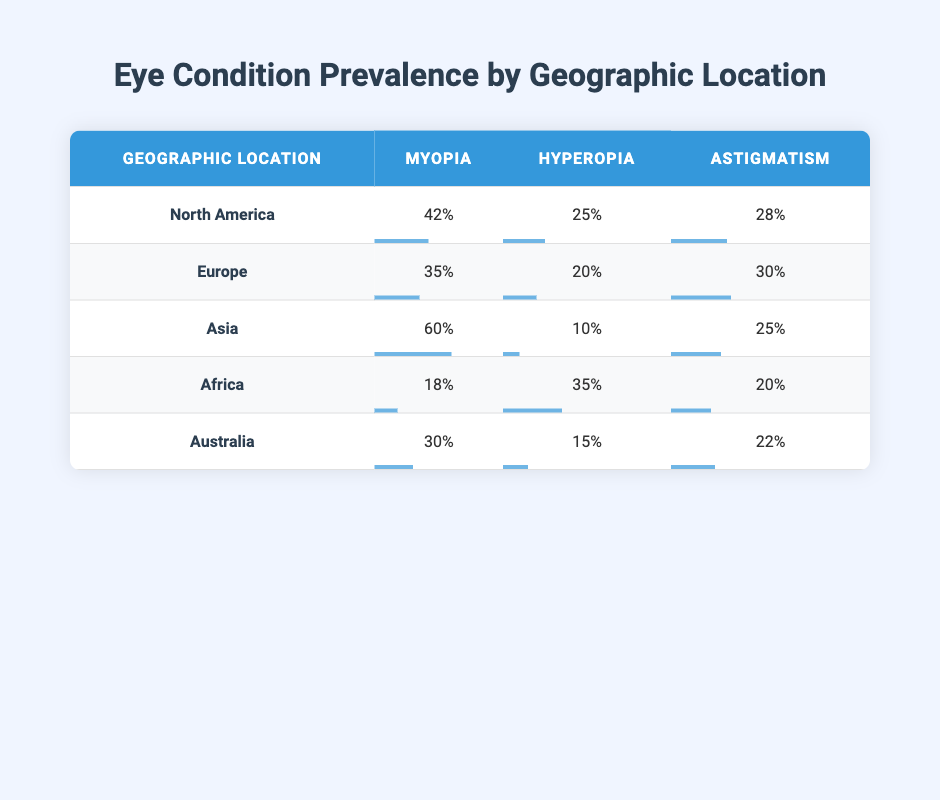What is the prevalence percentage of Myopia in Asia? According to the table, the prevalence of Myopia in Asia is directly provided in the row for Asia, which states a percentage of 60%.
Answer: 60% Which geographic location has the highest prevalence of Hyperopia? By comparing the Hyperopia prevalence percentages across all locations listed in the table, the highest percentage is found in Africa, where it is reported at 35%.
Answer: Africa What is the average prevalence of Astigmatism across all geographic locations? To calculate the average, we add the prevalence percentages of Astigmatism: 28% (North America) + 30% (Europe) + 25% (Asia) + 20% (Africa) + 22% (Australia) = 125%. There are 5 locations, so the average is 125% / 5 = 25%.
Answer: 25% Does Europe have a higher prevalence of Myopia than Australia? Europe has a Myopia prevalence of 35% while Australia has a prevalence of 30%. Since 35% is greater than 30%, the statement is true.
Answer: Yes What is the total prevalence of Myopia and Hyperopia in Africa? The prevalence of Myopia in Africa is 18% and Hyperopia is 35%. We add these two percentages: 18% + 35% = 53%.
Answer: 53% Which condition has the lowest prevalence percentage in North America? In North America, the three conditions listed have prevalence percentages of 42% (Myopia), 25% (Hyperopia), and 28% (Astigmatism). The lowest percentage among these is 25% for Hyperopia.
Answer: Hyperopia Are there any locations where the prevalence of Astigmatism is less than 20%? By examining the Astigmatism percentages for all locations, Africa (20%) is the lowest, and all other locations have higher percentages (North America: 28%, Europe: 30%, Asia: 25%, Australia: 22%). No location has less than 20%.
Answer: No What is the difference in prevalence between Myopia in Asia and Hyperopia in Africa? Myopia in Asia has a prevalence of 60% and Hyperopia in Africa has a prevalence of 35%. The difference is calculated as 60% - 35% = 25%.
Answer: 25% Which geographic location has the lowest Myopia prevalence among the ones listed? From the table, Africa (18%) has the lowest prevalence of Myopia when compared to North America (42%), Europe (35%), Asia (60%), and Australia (30%).
Answer: Africa 